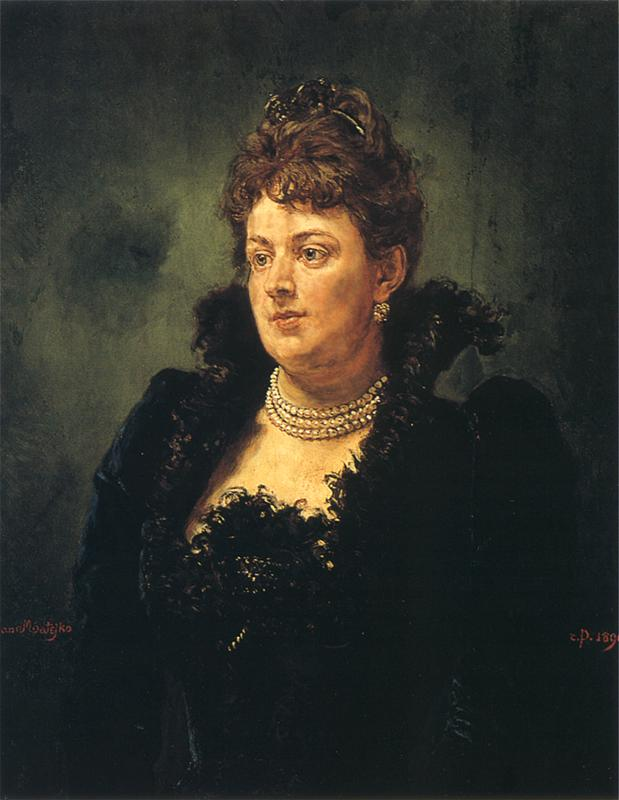If this portrait could come to life, what story do you think it would tell? Imagine the woman in this portrait stepping out of the canvas into the dimly lit room where it resides. Her elegance and poise suggest a background of privilege and refinement, perhaps a lady of significant societal standing. The story she might tell could be one of love and loss, of moments spent in grandeur and solitude alike. With a subtle smile, she might recount long walks in lush gardens, lavish banquets, and intimate gatherings. However, her pensive expression hints at personal trials and a lingering sadness, possibly due to unfulfilled desires or the weight of responsibilities. The pearls she wears might be heirlooms, carrying tales of family legacy and history. The lace on her dress whispers of unwavering attention to detail and an appreciation for the finer things in life. The dark background might symbolize the passing of time and the shadows of memories that follow her. As she speaks, the room is filled with a sense of grace and wistfulness, painting a vivid picture of a life rich with experience and depth. Could you create a poetic description of the portrait that encapsulates its essence? In shadows deep where whispers speak,
A lady poised in dusk’s mystique.
Her gaze afar, a soul unveiled,
In lace and pearls, a life detailed.
Through brush and hue, a moment caught,
Of light and dark, of dreams and thought.
Elegance framed in colors' dance,
A fleeting glimpse, a timeless trance.
The artist’s hand, with pride and skill,
Conveys a tale that lingers still.
In muted tones, her presence bright,
A beacon in the evening’s light. Imagine this woman in a realistic scenario of the late 19th century. This woman could be seen attending a grand evening soiree in the late 19th century, held in a beautifully adorned ballroom with crystal chandeliers casting a warm glow on the assembled guests. She moves gracefully through the crowd, her dress swishing softly with each step. She engages in polite conversation, her pearls catching the light as she nods and listens. Her demeanor is calm yet commanding, suggesting she is a well-respected figure in her social circle. As the evening progresses, she might step onto a balcony to take a moment of quiet reflection, looking out over the manicured gardens and moonlit night, a solitary figure amidst the revelry. Imagine a short scenario involving this woman in a modern setting. In a modern setting, this woman could be seen attending a formal gala at a prestigious art museum. Dressed in an elegant modern gown that echoes the classic lines of her historical attire, she mingles with art connoisseurs and professionals. She might pause before a contemporary piece, her keen eye appreciating the nuances of the artwork. Throughout the event, she exudes confidence and grace, engaging in insightful discussions about art and culture, her presence adding a touch of timeless elegance to the evening. 